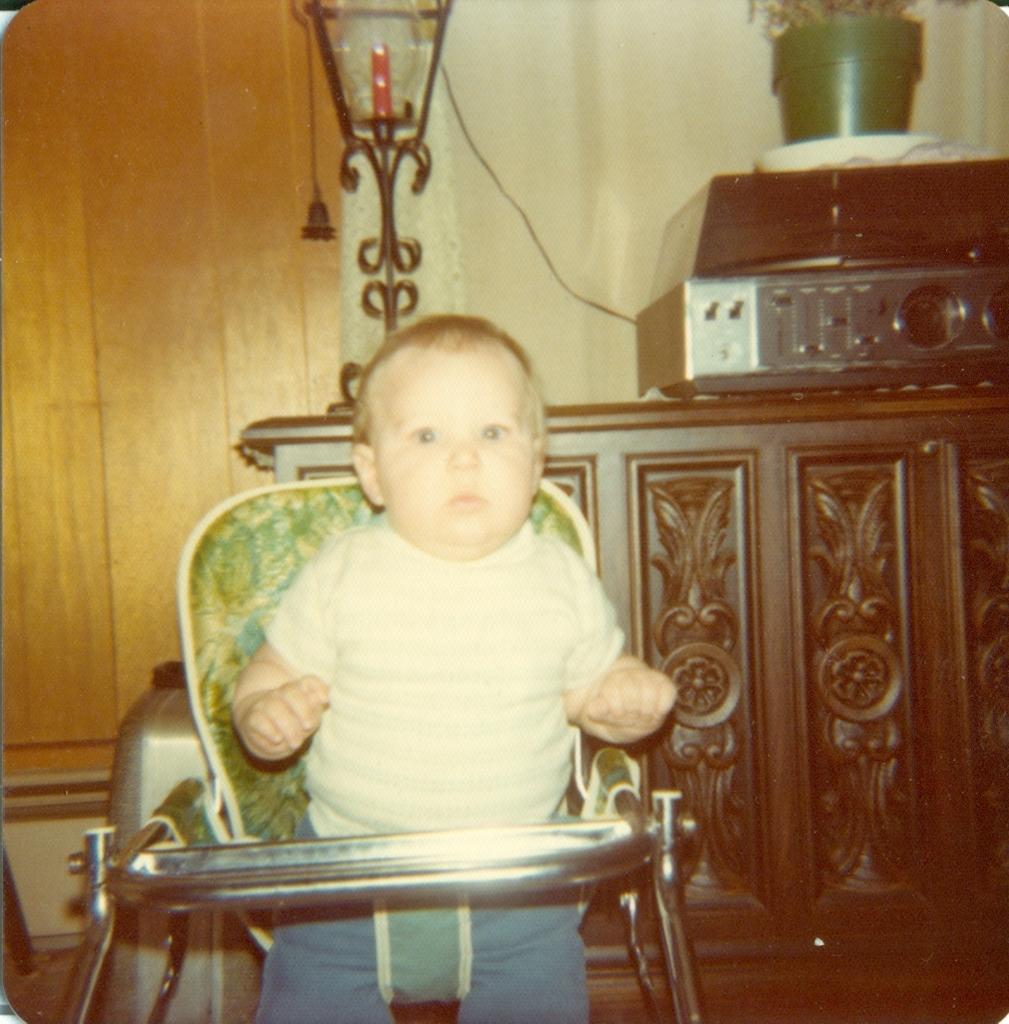In one or two sentences, can you explain what this image depicts? In this image there is a kid wearing white color dress playing with a toy vehicle and at the background of the image there is a lamp. 